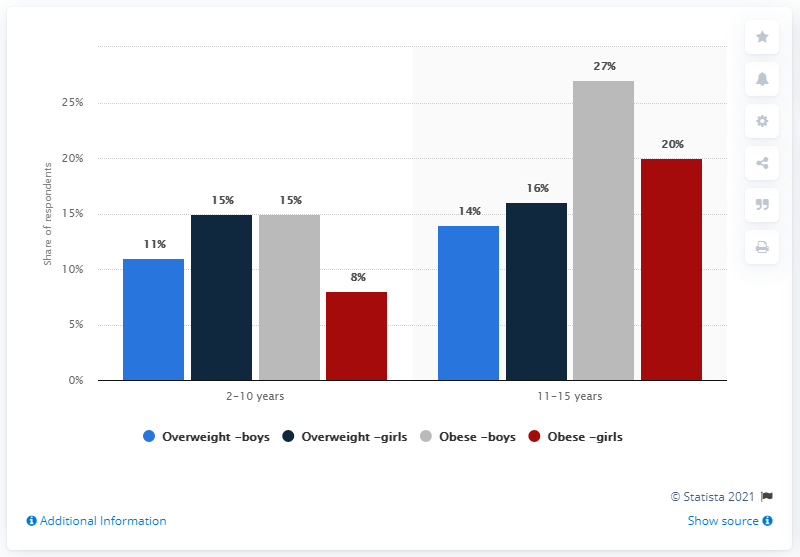Outline some significant characteristics in this image. The obese category has the largest share among 11-15 year old boys. The percentage of obese 11-15 year old boys in the population is approximately 27%. 